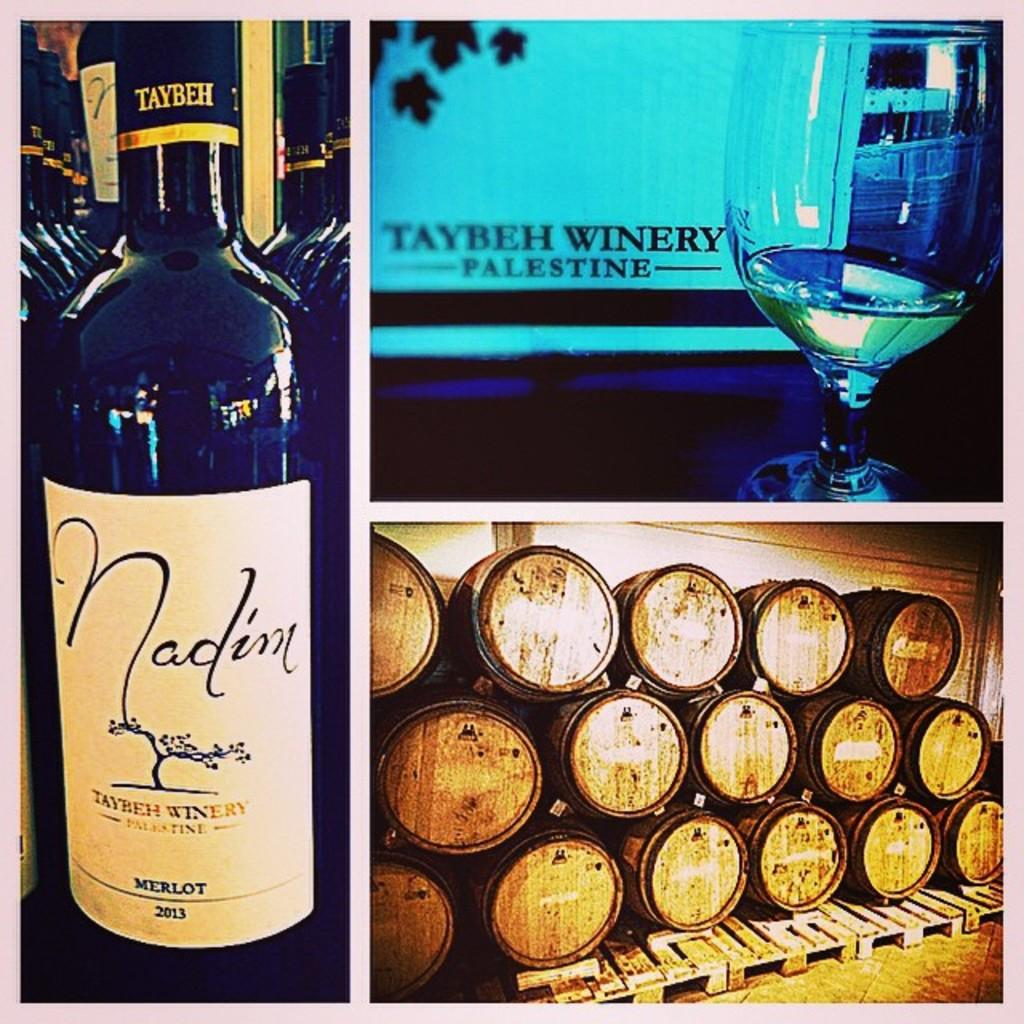<image>
Provide a brief description of the given image. Nadim Merlot is featured with barrels and a glass as well 